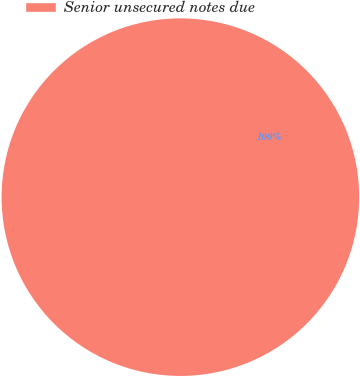Convert chart to OTSL. <chart><loc_0><loc_0><loc_500><loc_500><pie_chart><fcel>Senior unsecured notes due<nl><fcel>100.0%<nl></chart> 